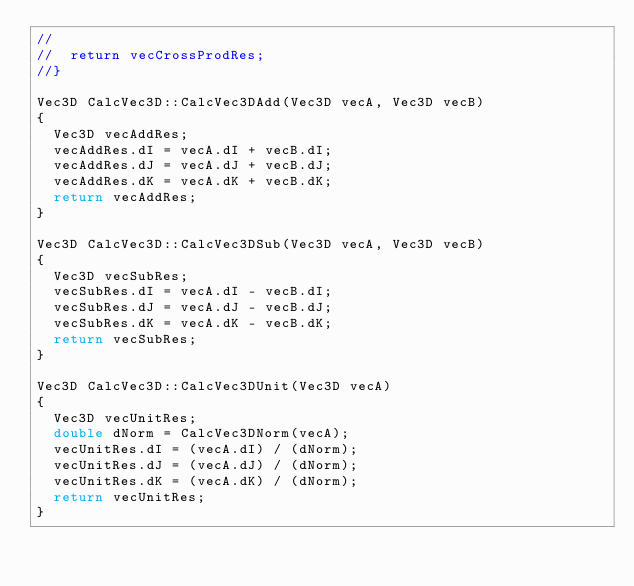Convert code to text. <code><loc_0><loc_0><loc_500><loc_500><_C++_>//
//  return vecCrossProdRes;
//}

Vec3D CalcVec3D::CalcVec3DAdd(Vec3D vecA, Vec3D vecB)
{
  Vec3D vecAddRes;
  vecAddRes.dI = vecA.dI + vecB.dI;
  vecAddRes.dJ = vecA.dJ + vecB.dJ;
  vecAddRes.dK = vecA.dK + vecB.dK;
  return vecAddRes;
}

Vec3D CalcVec3D::CalcVec3DSub(Vec3D vecA, Vec3D vecB)
{
  Vec3D vecSubRes;
  vecSubRes.dI = vecA.dI - vecB.dI;
  vecSubRes.dJ = vecA.dJ - vecB.dJ;
  vecSubRes.dK = vecA.dK - vecB.dK;
  return vecSubRes;
}

Vec3D CalcVec3D::CalcVec3DUnit(Vec3D vecA)
{
  Vec3D vecUnitRes;
  double dNorm = CalcVec3DNorm(vecA);
  vecUnitRes.dI = (vecA.dI) / (dNorm);
  vecUnitRes.dJ = (vecA.dJ) / (dNorm);
  vecUnitRes.dK = (vecA.dK) / (dNorm);
  return vecUnitRes;
}</code> 